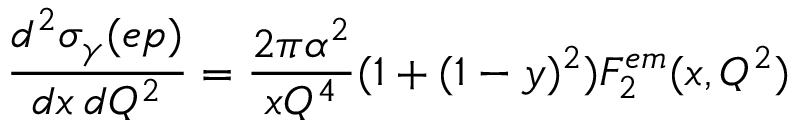<formula> <loc_0><loc_0><loc_500><loc_500>\frac { d ^ { 2 } \sigma _ { \gamma } ( e p ) } { d x \, d Q ^ { 2 } } = \frac { 2 \pi \alpha ^ { 2 } } { x Q ^ { 4 } } ( 1 + ( 1 - y ) ^ { 2 } ) F _ { 2 } ^ { e m } ( x , Q ^ { 2 } )</formula> 